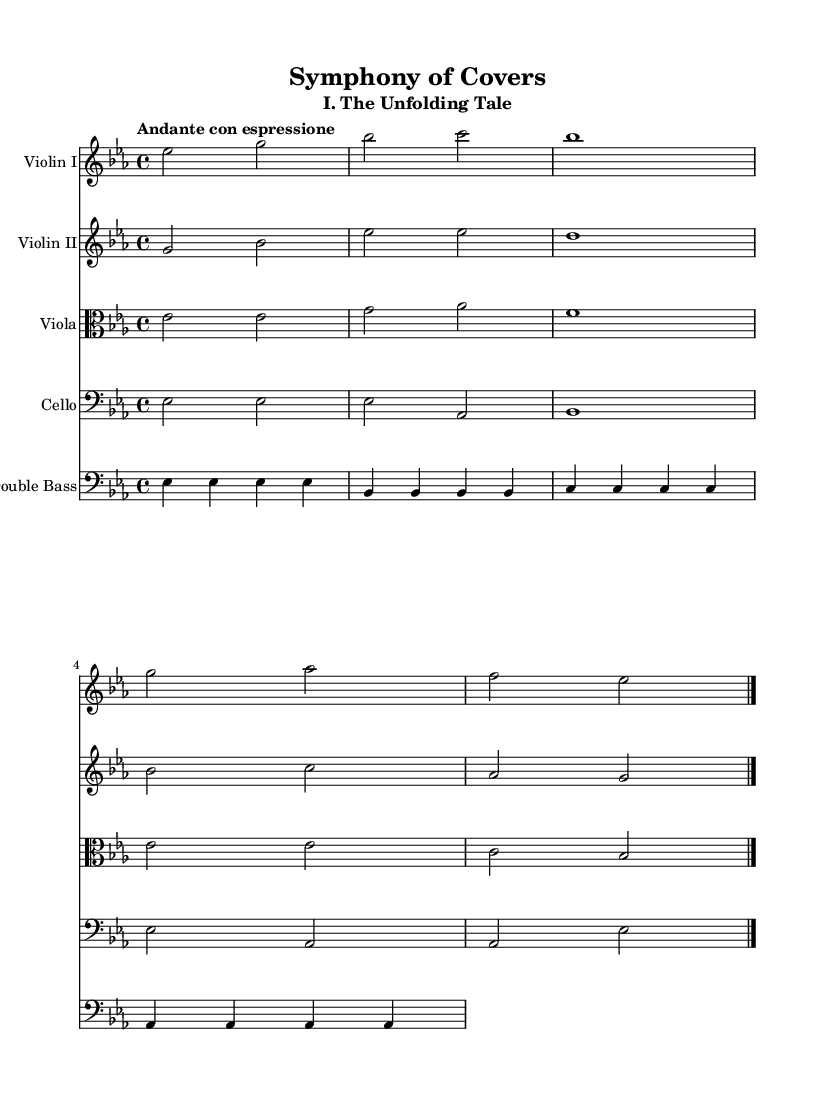What is the key signature of this music? The key signature is E flat major, which has three flats (B flat, E flat, and A flat). This is determined by the presence of the flat symbols placed on the staff.
Answer: E flat major What is the time signature of this piece? The time signature is 4/4, indicated at the beginning of the music. This means there are four beats in each measure and the quarter note gets one beat.
Answer: 4/4 What is the tempo marking? The tempo marking is "Andante con espressione," which indicates a moderately slow pace with some expressiveness. This is found written at the beginning of the score.
Answer: Andante con espressione How many instruments are featured in this score? The score features five instruments: Violin I, Violin II, Viola, Cello, and Double Bass. Each instrument is indicated with its own staff at the start of the score.
Answer: Five What is the most prominent note in the first measure for Violin I? The most prominent note in the first measure for Violin I is E flat, which is the first note played and is fundamental to establishing the piece's tonal center.
Answer: E flat Which clef is used for the Viola part? The Viola part uses the alto clef, which is identifiable by the symbol at the beginning of the staff specifically designed for instruments in the viola range.
Answer: Alto clef How many measures are there in the provided music? The provided music consists of five measures, which can be counted easily by looking at the vertical lines separating the measures in the score.
Answer: Five 